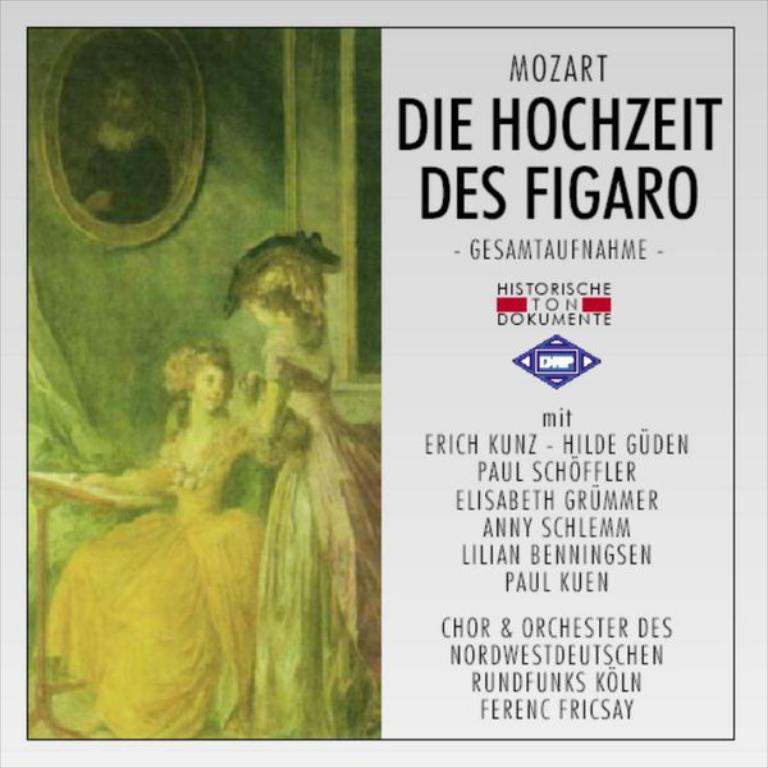<image>
Share a concise interpretation of the image provided. A music cover for Mozart entitled Die Hochzeit Des Figaro. 